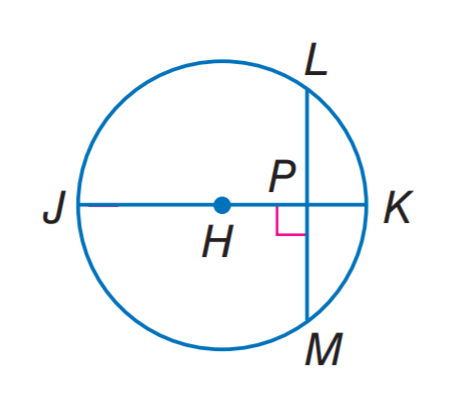Answer the mathemtical geometry problem and directly provide the correct option letter.
Question: In H, the diameter is 18, L M = 12, and m \widehat L M = 84. Find m \widehat L K.
Choices: A: 21 B: 42 C: 63 D: 84 B 